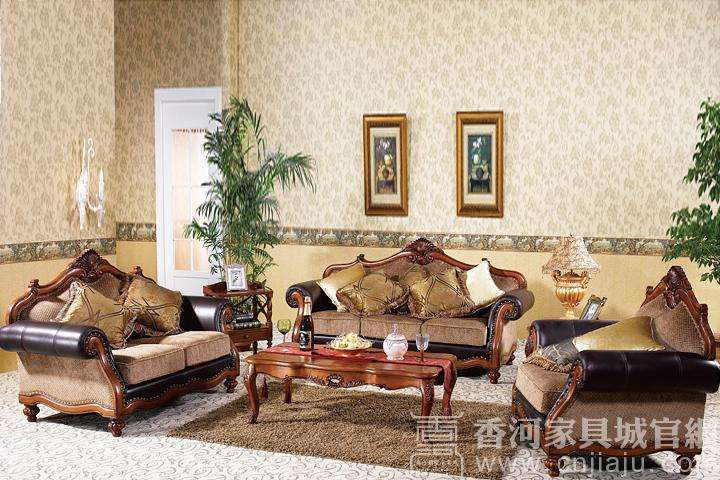What could be the function of the room depicted in the image? The room in the image appears to be a formal living room or sitting area designed for entertaining guests, holding conversations, or enjoying quiet relaxation. The selection of multiple sofas around a central table suggests a space meant for social interaction and comfort. 